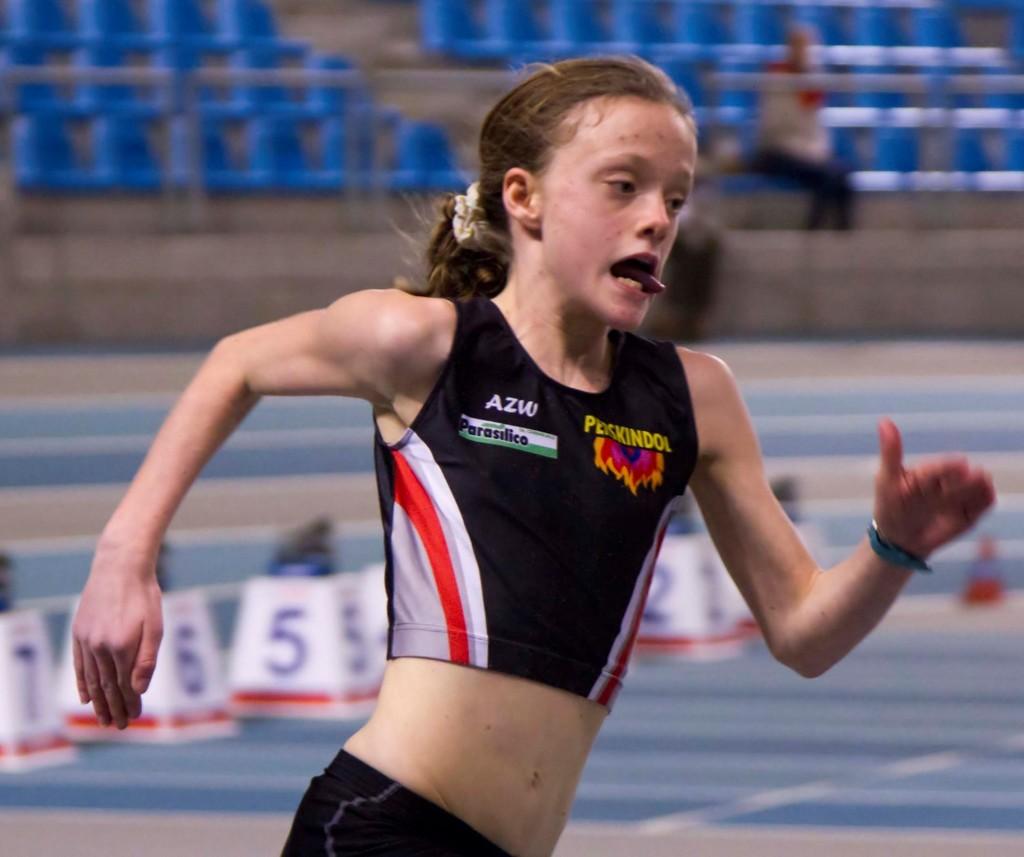What is the sponsor on the shirt?
Your response must be concise. Parasilico. 